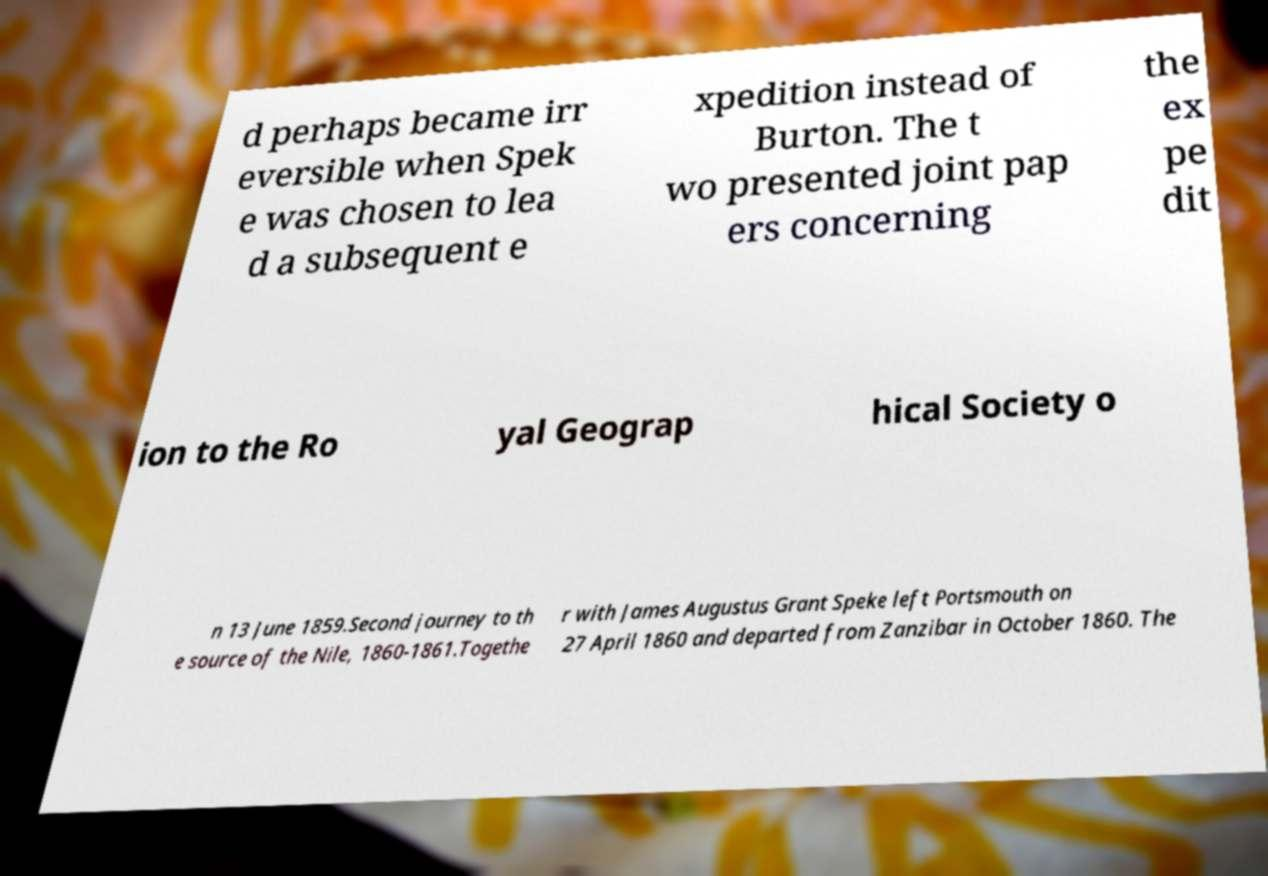Could you extract and type out the text from this image? d perhaps became irr eversible when Spek e was chosen to lea d a subsequent e xpedition instead of Burton. The t wo presented joint pap ers concerning the ex pe dit ion to the Ro yal Geograp hical Society o n 13 June 1859.Second journey to th e source of the Nile, 1860-1861.Togethe r with James Augustus Grant Speke left Portsmouth on 27 April 1860 and departed from Zanzibar in October 1860. The 